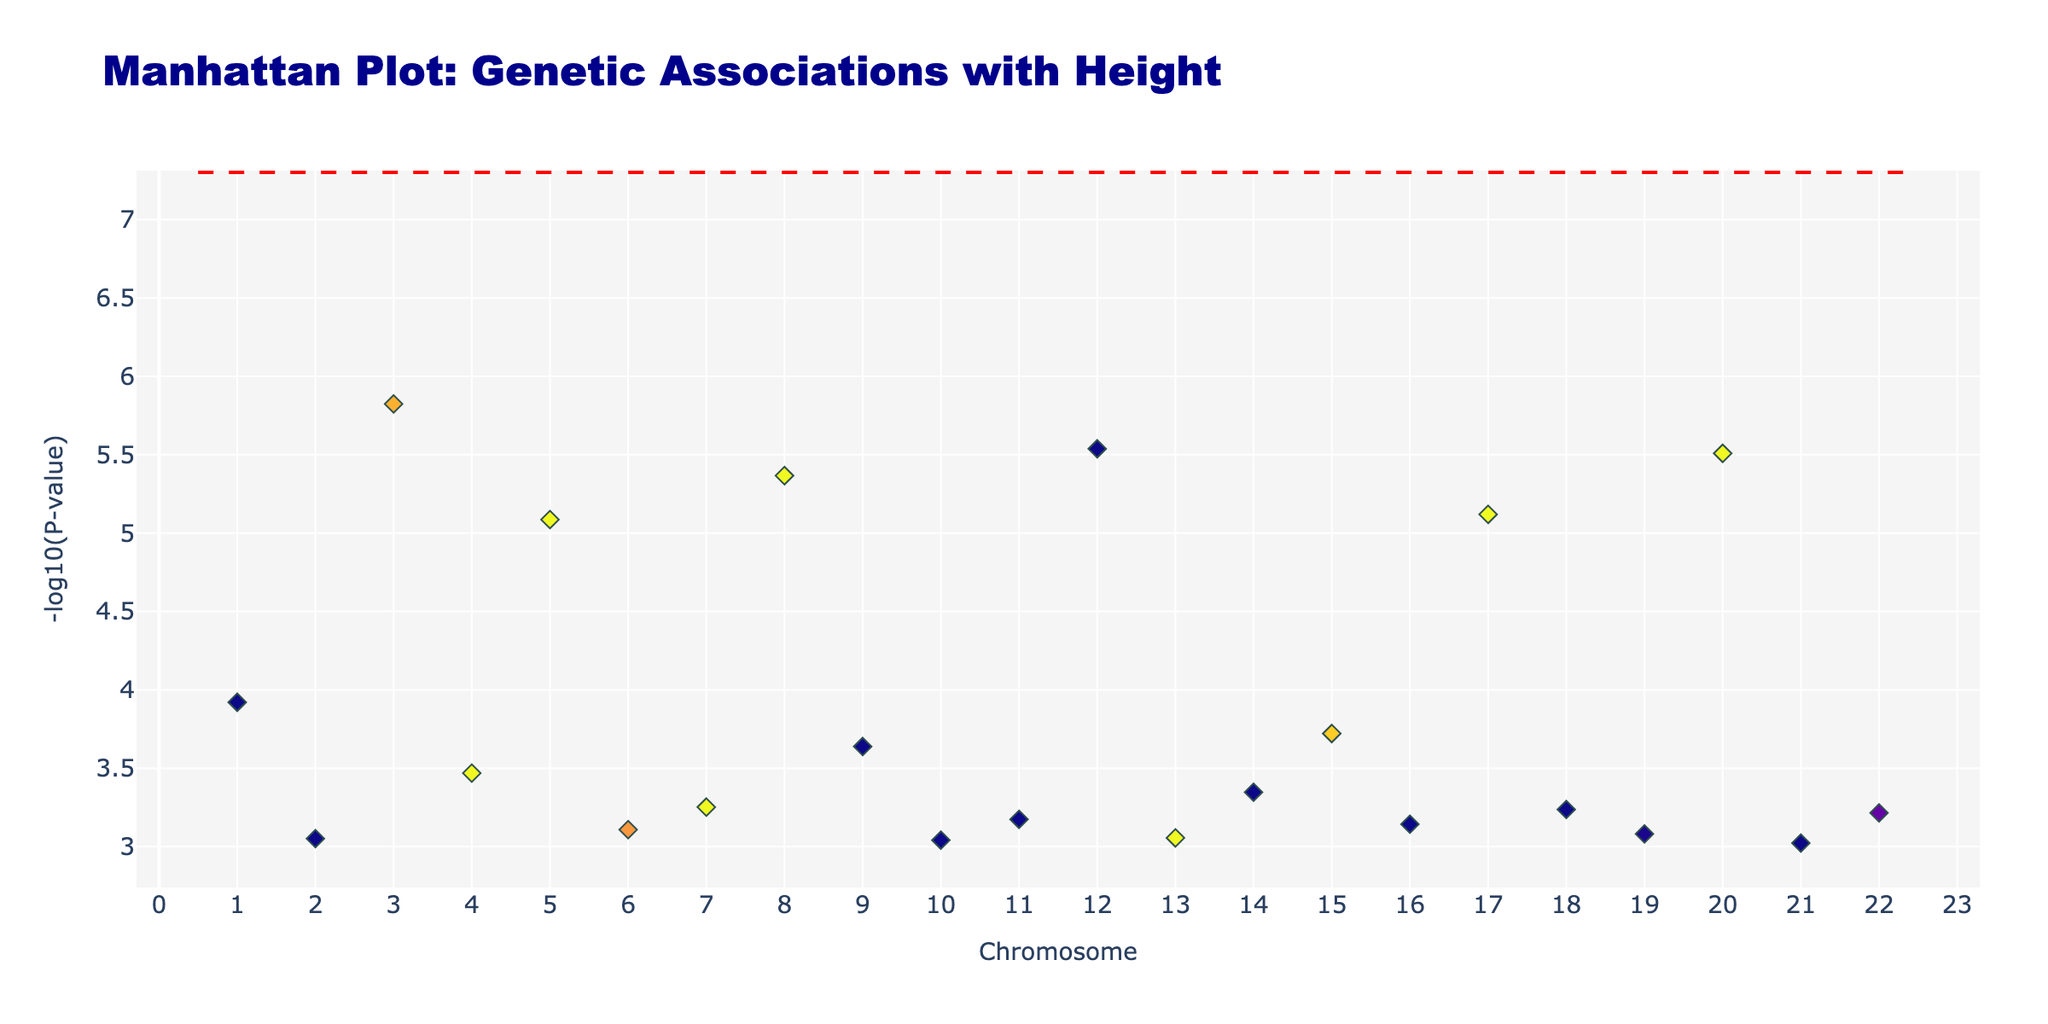What's the title of the plot? The title of a plot is often located at the top of the figure. In this case, it reads: "Manhattan Plot: Genetic Associations with Height".
Answer: Manhattan Plot: Genetic Associations with Height What is on the x-axis? The label on the x-axis indicates what it represents. Here, it is labeled as "Chromosome," representing the chromosome number from 1 to 22.
Answer: Chromosome What does the y-axis represent? The y-axis label tells us what is being measured. Here, the label "-log10(P-value)" indicates it represents the negative logarithm (base 10) of the p-value.
Answer: -log10(P-value) How many chromosomes are shown in the plot? Chromosomes are marked on the x-axis. The ticks range from 1 to 22, so there are 22 chromosomes displayed.
Answer: 22 Which chromosome has the lowest p-value SNP? The chromosome with the highest position on the y-axis indicates the lowest p-value because -log10(p-value) increases as the p-value decreases. Chromosome 3 has the SNP with the highest y-axis position.
Answer: Chromosome 3 Which SNP has the lowest p-value? The label of the SNP rs724016 is shown when hovering over the highest point on the y-axis for Chromosome 3. This position corresponds to the lowest p-value.
Answer: rs724016 How many SNPs have a -log10(P-value) greater than 5? To find this, count the number of points above the dotted red line, which marks the location of -log10(5e-8).
Answer: 0 Which chromosome has the highest number of data points? Comparing the markers associated with each chromosome within the figure, count or visually estimate the chromosome with the most dense array of points. Chromosome 2 has the highest number.
Answer: Chromosome 2 What color are the markers for Chromosome 8? Identify the unique color assigned to Chromosome 8 markers in the plot. These markers are colored in a shade of blue.
Answer: Blue What trend do the significance points follow? Manhattan plots usually present points in horizontal bands parallel to the x-axis. Points are evaluated on the y-axis to reflect significance. Here, the SNP points for each chromosome show this pattern.
Answer: Horizontal bands across chromosomes 